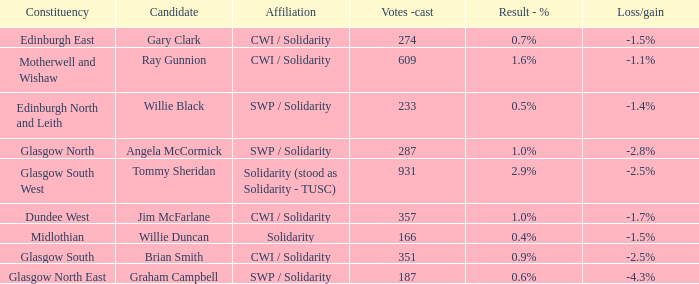Who was the candidate when the result - % was 0.4%? Willie Duncan. 